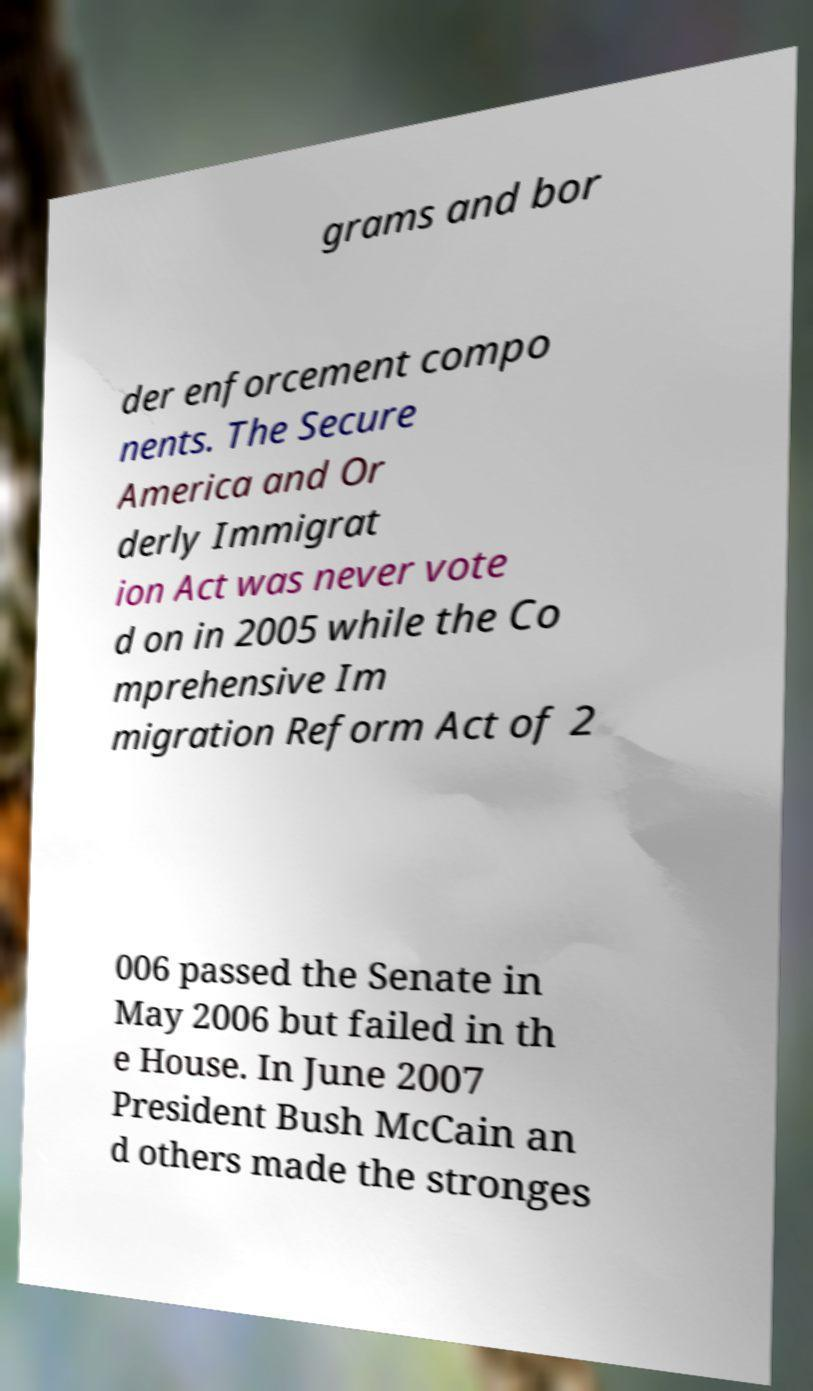I need the written content from this picture converted into text. Can you do that? grams and bor der enforcement compo nents. The Secure America and Or derly Immigrat ion Act was never vote d on in 2005 while the Co mprehensive Im migration Reform Act of 2 006 passed the Senate in May 2006 but failed in th e House. In June 2007 President Bush McCain an d others made the stronges 